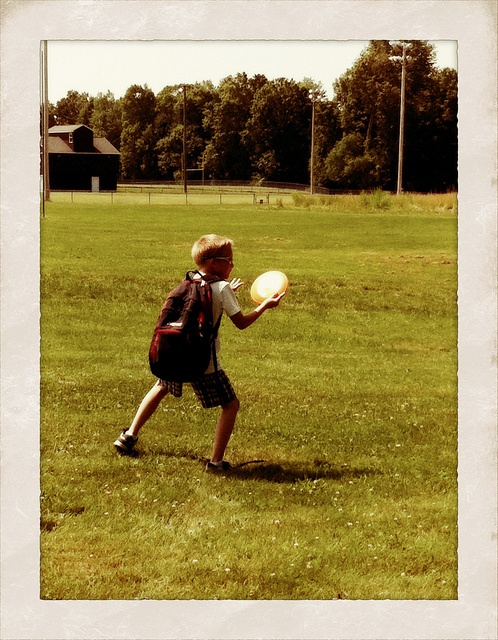Describe the objects in this image and their specific colors. I can see people in tan, black, maroon, and olive tones, backpack in tan, black, maroon, and brown tones, and frisbee in tan, beige, and khaki tones in this image. 